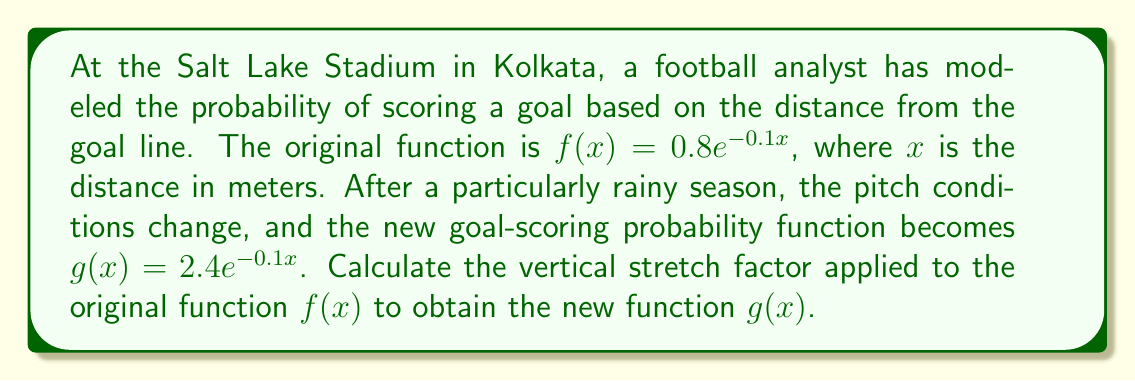Can you answer this question? To find the vertical stretch factor, we need to compare the new function $g(x)$ with the original function $f(x)$. Let's approach this step-by-step:

1) The general form of a vertical stretch is:
   $g(x) = a \cdot f(x)$, where $a$ is the stretch factor

2) We have:
   $f(x) = 0.8e^{-0.1x}$
   $g(x) = 2.4e^{-0.1x}$

3) We can rewrite $g(x)$ in terms of $f(x)$:
   $g(x) = 2.4e^{-0.1x} = 3 \cdot (0.8e^{-0.1x}) = 3 \cdot f(x)$

4) From this, we can see that:
   $a = 3$

5) Therefore, the vertical stretch factor is 3, meaning the new function $g(x)$ is stretched vertically by a factor of 3 compared to the original function $f(x)$.
Answer: 3 